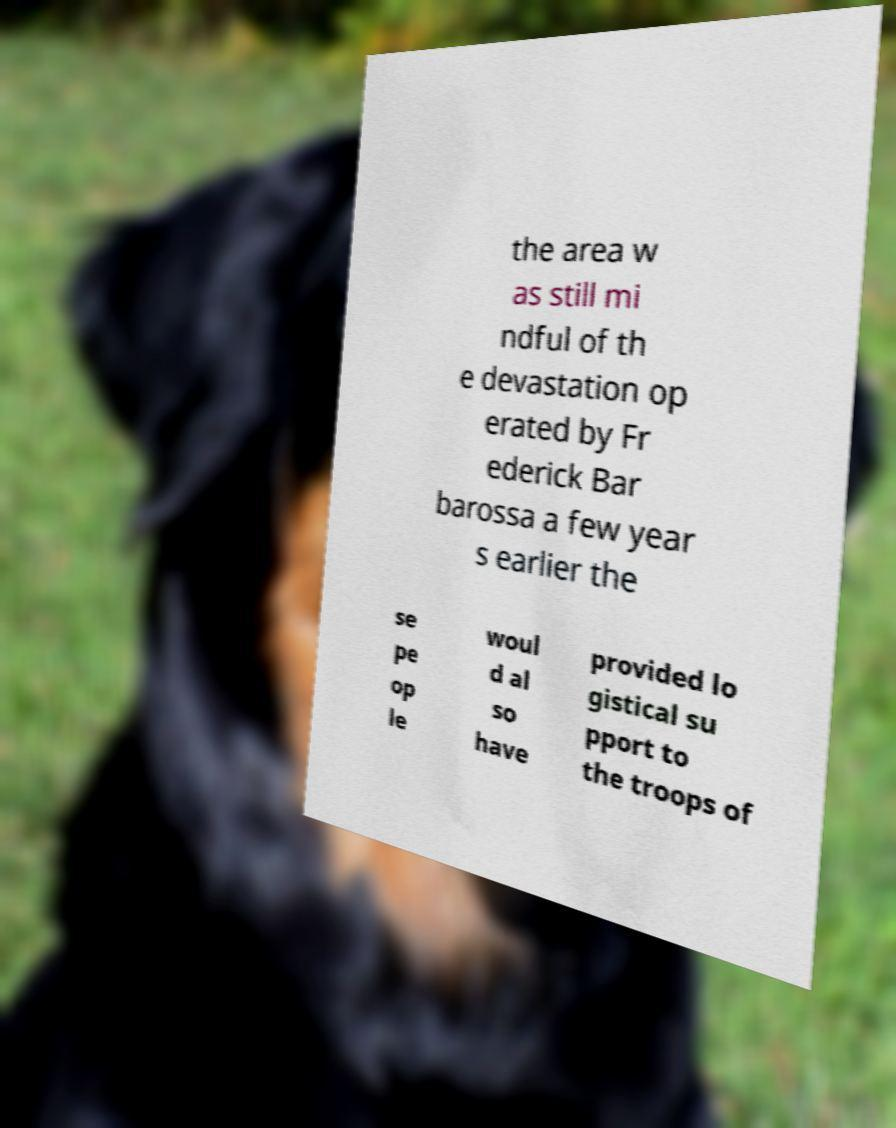There's text embedded in this image that I need extracted. Can you transcribe it verbatim? the area w as still mi ndful of th e devastation op erated by Fr ederick Bar barossa a few year s earlier the se pe op le woul d al so have provided lo gistical su pport to the troops of 